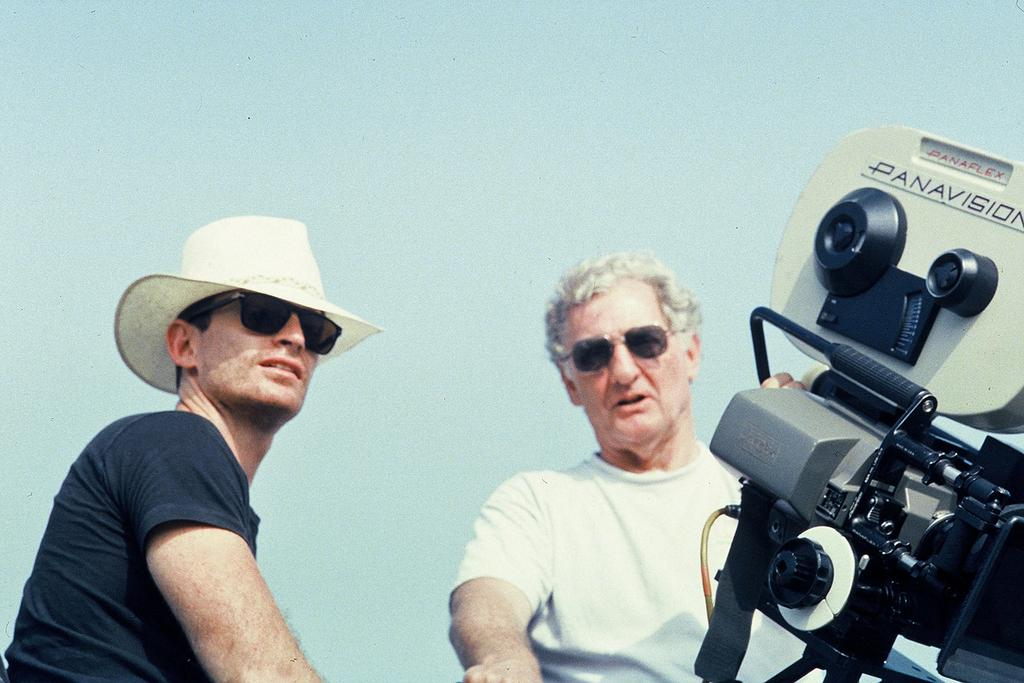How many people are present in the image? There are two people in the image. What is one of the individuals doing in the image? A man is holding a camera in his hands. What type of cord is being used by the man to take the picture? There is no cord visible in the image; the man is simply holding the camera in his hands. What tool is being used to cut the camera's strap in the image? There are no scissors or knives present in the image, and the camera's strap is not being cut. 